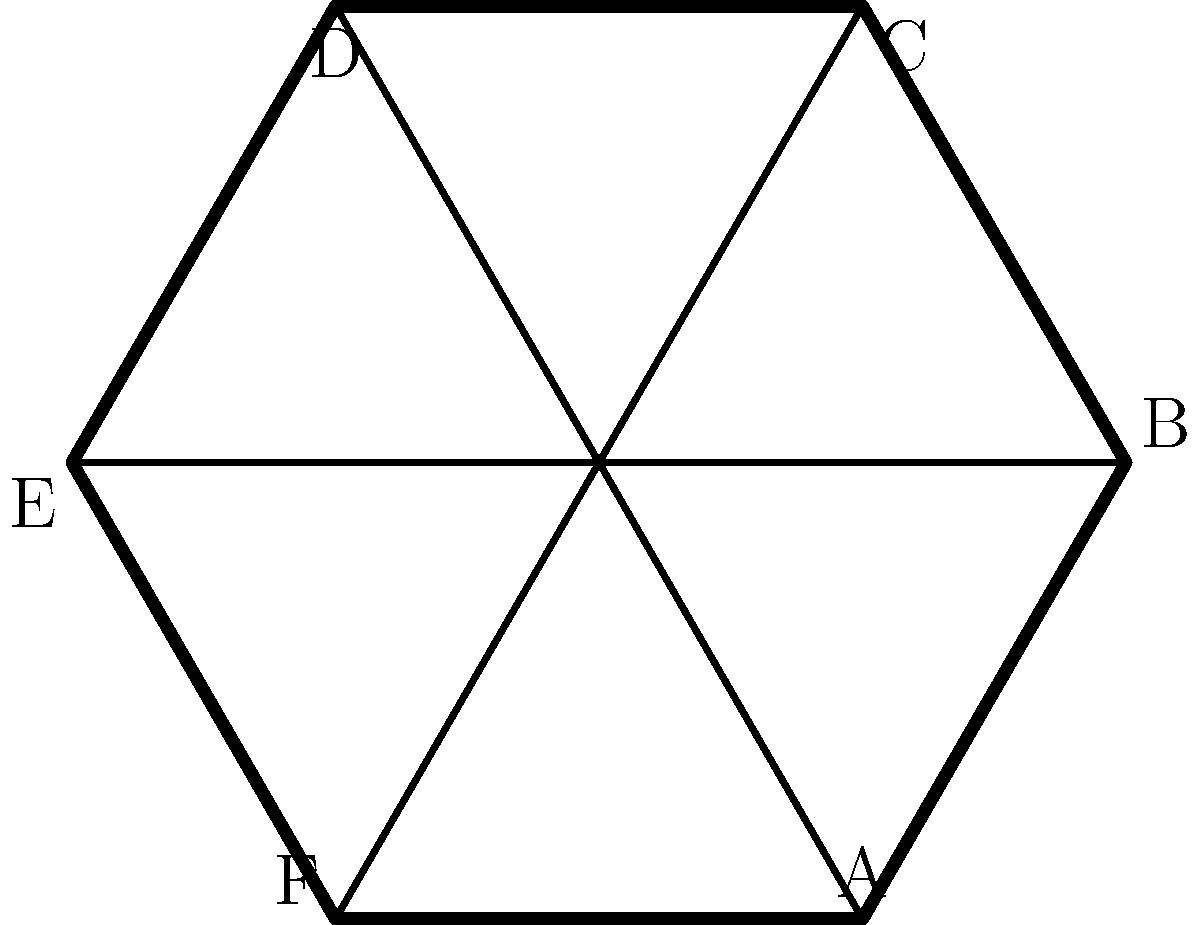A hexagonal dog yard is constructed using six interlocking fence panels (A, B, C, D, E, F) as shown in the diagram. Each panel can be rotated 180° to change its orientation. How many distinct arrangements of the fence can be created by rotating and rearranging the panels, considering that rotations of the entire structure are considered identical? To solve this problem, we'll use group theory concepts:

1. First, we need to understand that we have 6 panels, each with 2 possible orientations (normal or rotated 180°).

2. The total number of ways to arrange 6 panels is 6! = 720.

3. For each arrangement, we have 2^6 = 64 ways to orient the panels (2 choices for each of the 6 panels).

4. However, rotations of the entire structure are considered identical. The hexagon has 12 rotational symmetries (6 rotations * 2 reflections).

5. Using Burnside's lemma, we can calculate the number of distinct arrangements:

   Let G be the group of 12 rotational symmetries, and X be the set of all possible fence configurations.

   The number of distinct arrangements is given by:
   
   $$ \frac{1}{|G|} \sum_{g \in G} |X^g| $$

   Where $|X^g|$ is the number of configurations fixed by symmetry $g$.

6. For the identity element, all 720 * 64 = 46,080 configurations are fixed.

7. For the 5 non-identity rotations, no configurations are fixed.

8. For the 6 reflections, the configurations where opposite panels have the same orientation are fixed. There are 2^3 * 6! / 2 = 2,880 such configurations.

9. Applying Burnside's lemma:

   $$ \frac{1}{12} (46080 + 0 + 0 + 0 + 0 + 0 + 2880 + 2880 + 2880 + 2880 + 2880 + 2880) = 5,280 $$

Therefore, there are 5,280 distinct arrangements of the fence.
Answer: 5,280 distinct arrangements 